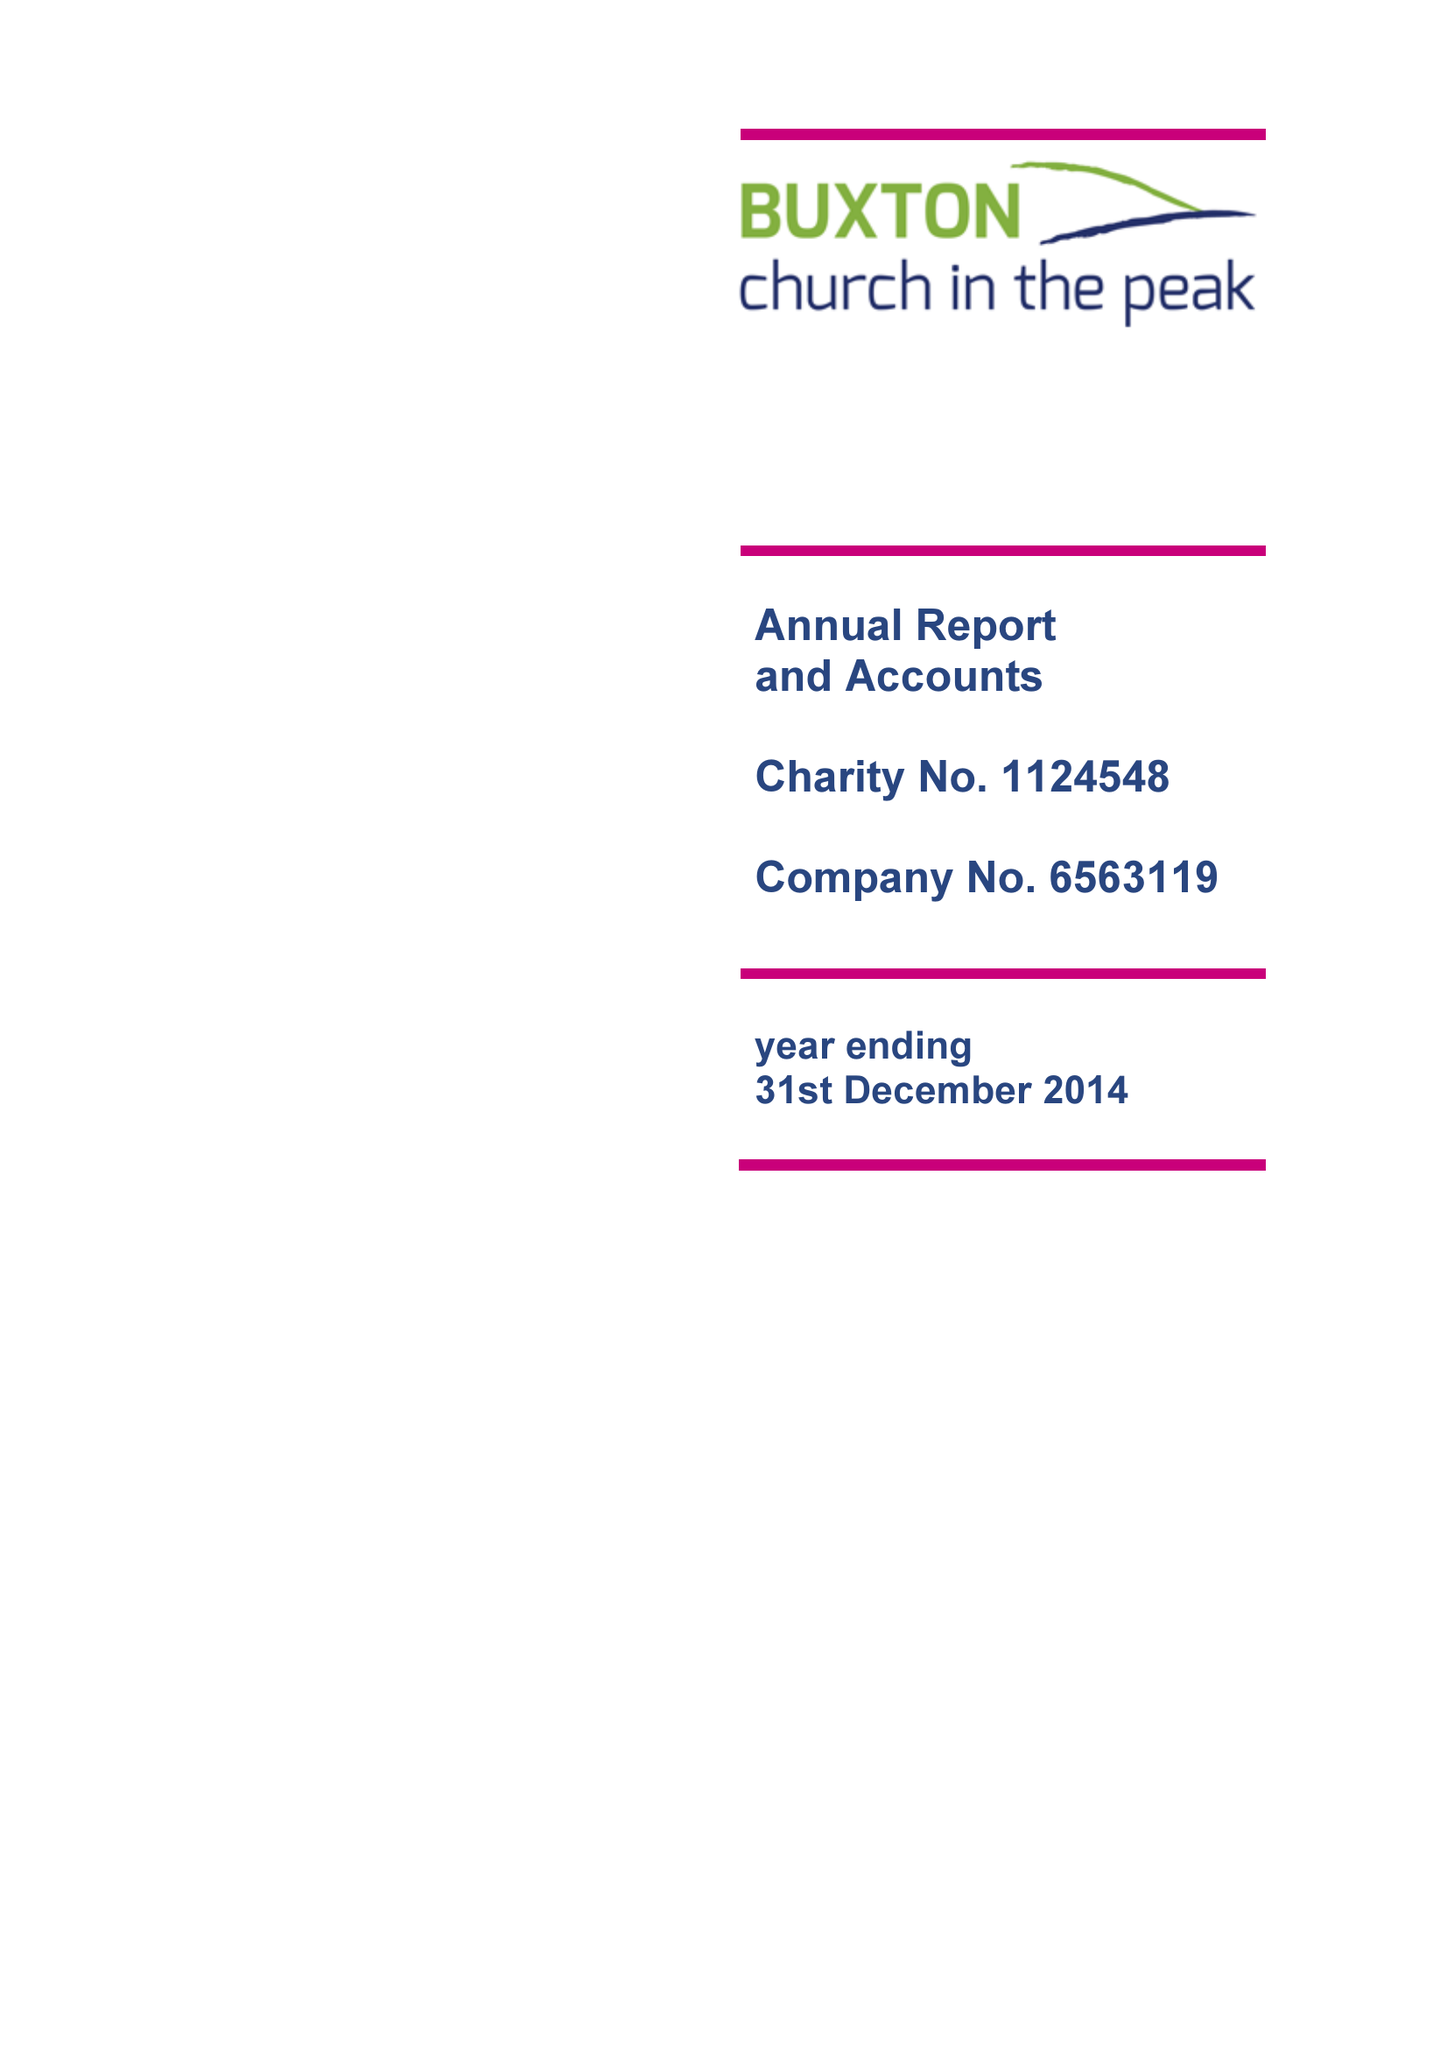What is the value for the report_date?
Answer the question using a single word or phrase. 2014-12-31 